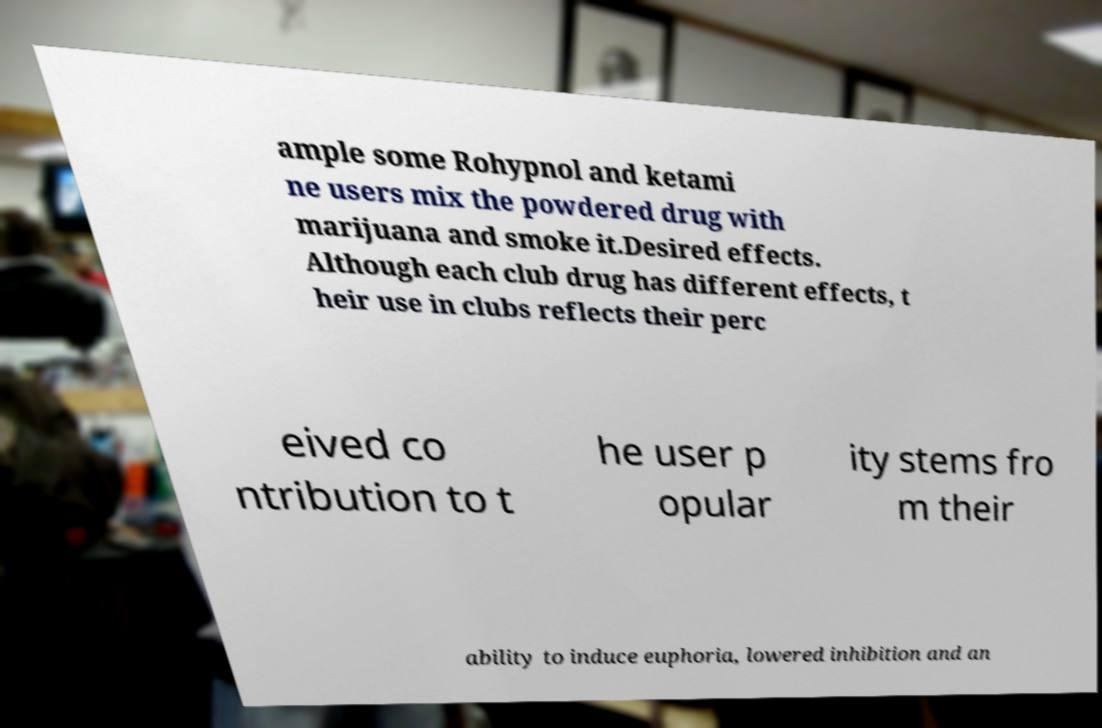Could you assist in decoding the text presented in this image and type it out clearly? ample some Rohypnol and ketami ne users mix the powdered drug with marijuana and smoke it.Desired effects. Although each club drug has different effects, t heir use in clubs reflects their perc eived co ntribution to t he user p opular ity stems fro m their ability to induce euphoria, lowered inhibition and an 